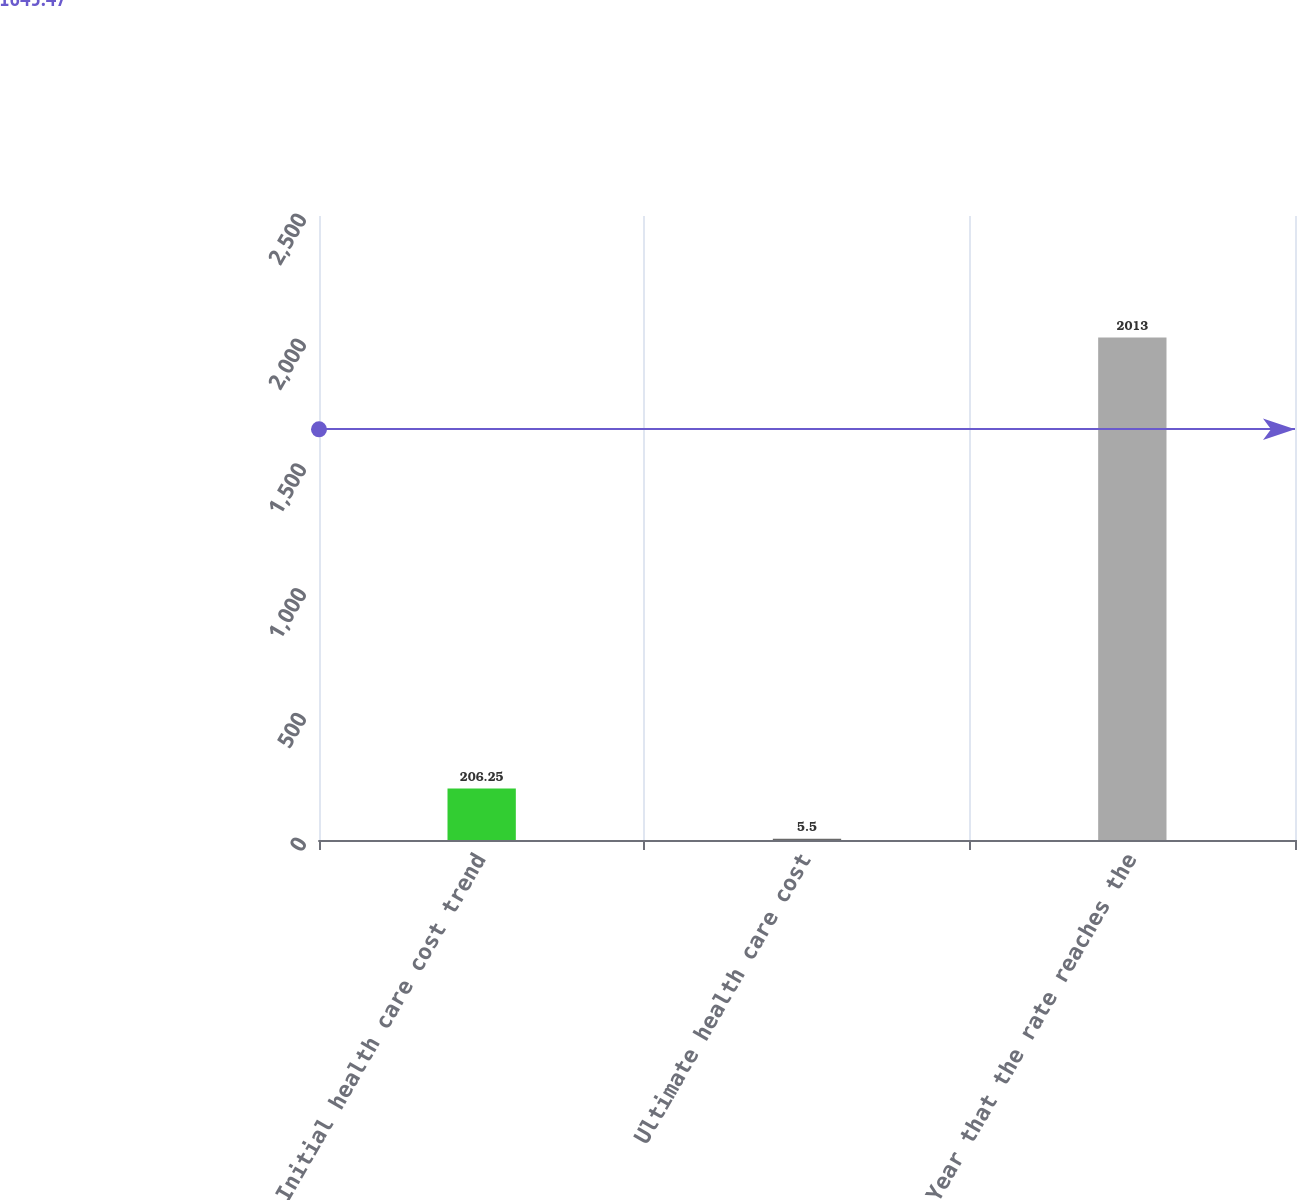Convert chart. <chart><loc_0><loc_0><loc_500><loc_500><bar_chart><fcel>Initial health care cost trend<fcel>Ultimate health care cost<fcel>Year that the rate reaches the<nl><fcel>206.25<fcel>5.5<fcel>2013<nl></chart> 